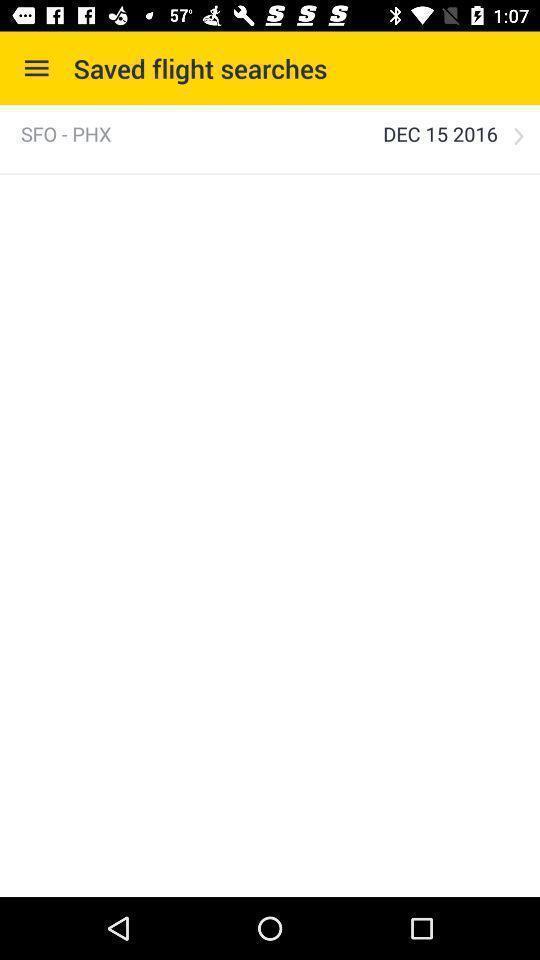Provide a description of this screenshot. Screen showing saved flight searches. 